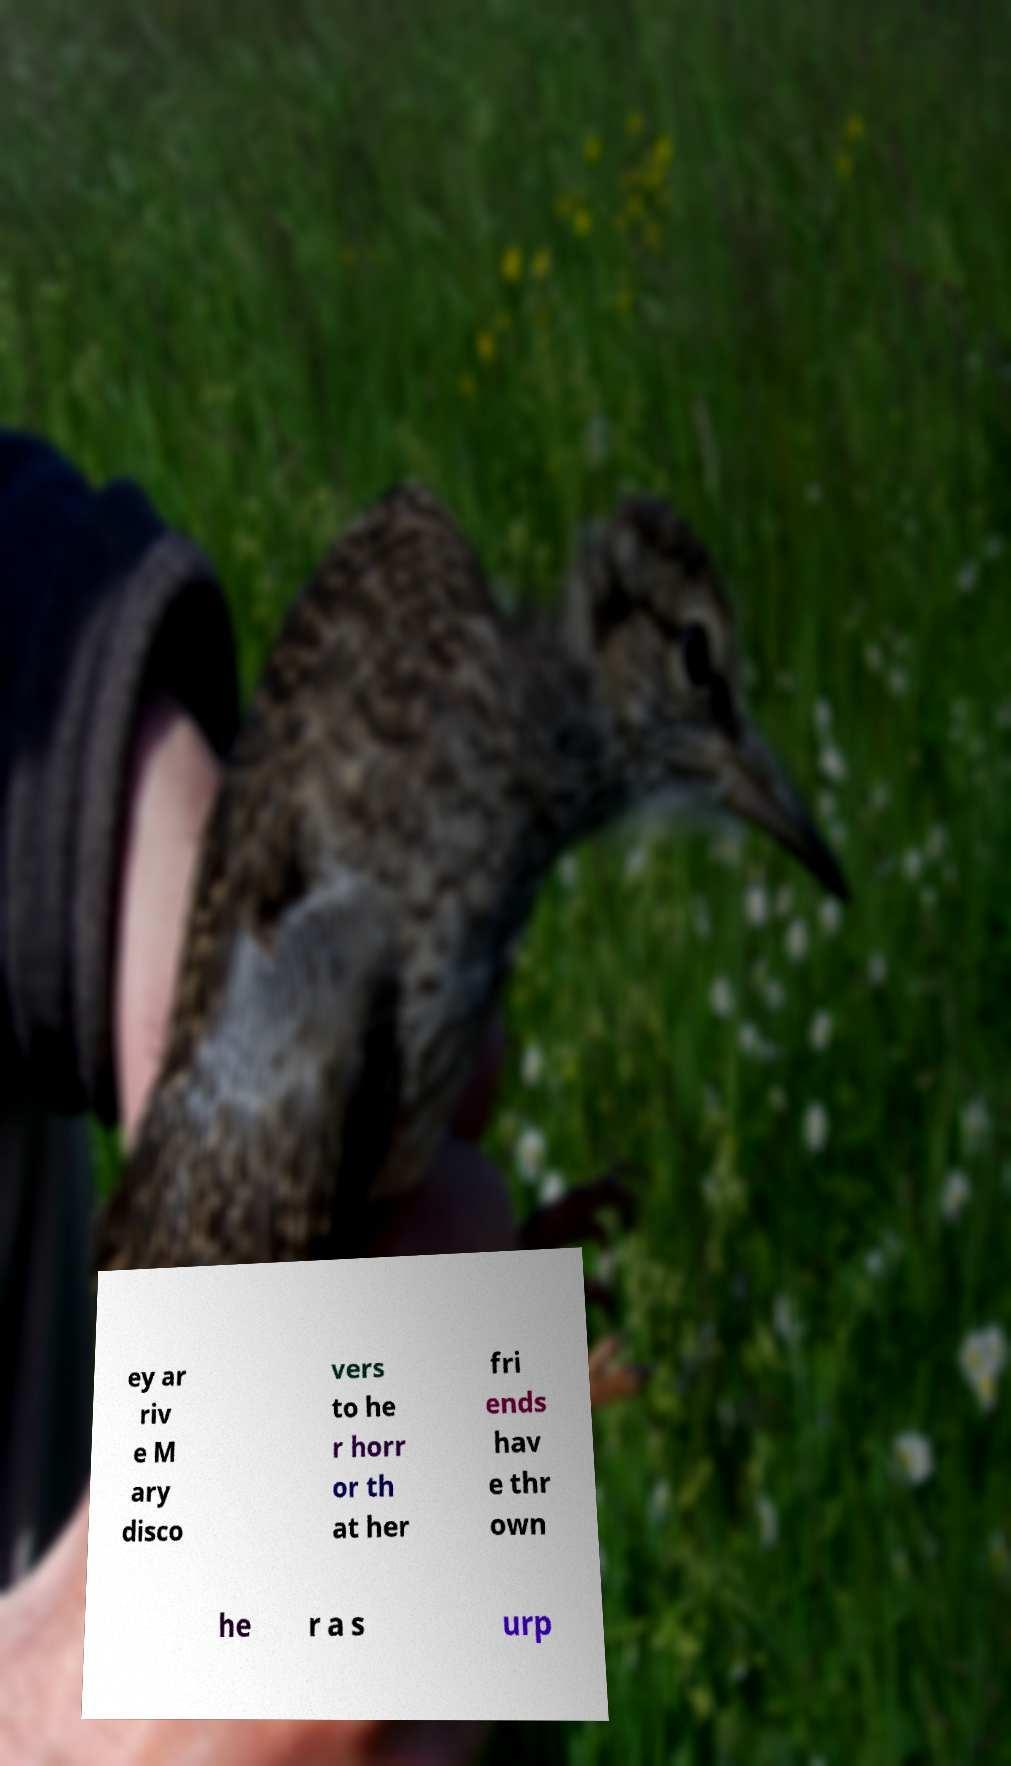Could you assist in decoding the text presented in this image and type it out clearly? ey ar riv e M ary disco vers to he r horr or th at her fri ends hav e thr own he r a s urp 